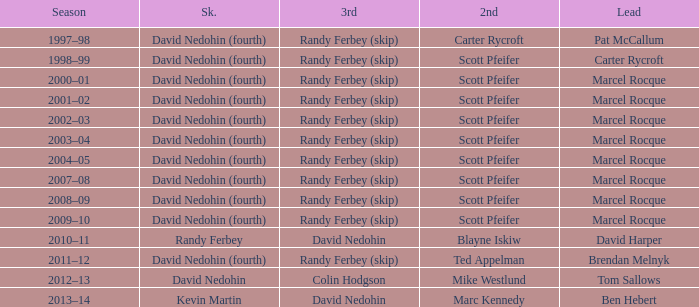Which Second has a Third of david nedohin, and a Lead of ben hebert? Marc Kennedy. 